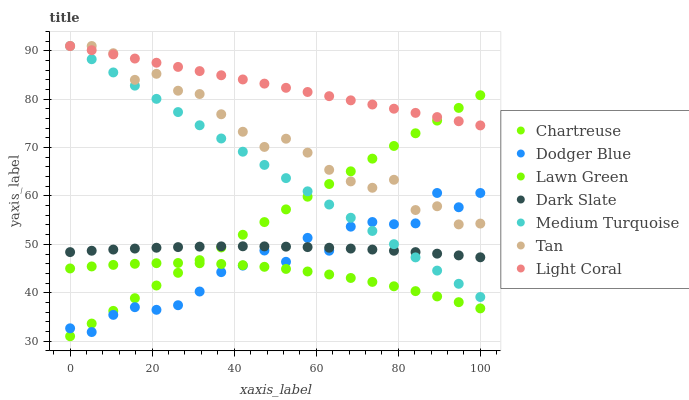Does Lawn Green have the minimum area under the curve?
Answer yes or no. Yes. Does Light Coral have the maximum area under the curve?
Answer yes or no. Yes. Does Dark Slate have the minimum area under the curve?
Answer yes or no. No. Does Dark Slate have the maximum area under the curve?
Answer yes or no. No. Is Chartreuse the smoothest?
Answer yes or no. Yes. Is Dodger Blue the roughest?
Answer yes or no. Yes. Is Light Coral the smoothest?
Answer yes or no. No. Is Light Coral the roughest?
Answer yes or no. No. Does Chartreuse have the lowest value?
Answer yes or no. Yes. Does Dark Slate have the lowest value?
Answer yes or no. No. Does Tan have the highest value?
Answer yes or no. Yes. Does Dark Slate have the highest value?
Answer yes or no. No. Is Lawn Green less than Tan?
Answer yes or no. Yes. Is Medium Turquoise greater than Lawn Green?
Answer yes or no. Yes. Does Medium Turquoise intersect Tan?
Answer yes or no. Yes. Is Medium Turquoise less than Tan?
Answer yes or no. No. Is Medium Turquoise greater than Tan?
Answer yes or no. No. Does Lawn Green intersect Tan?
Answer yes or no. No. 